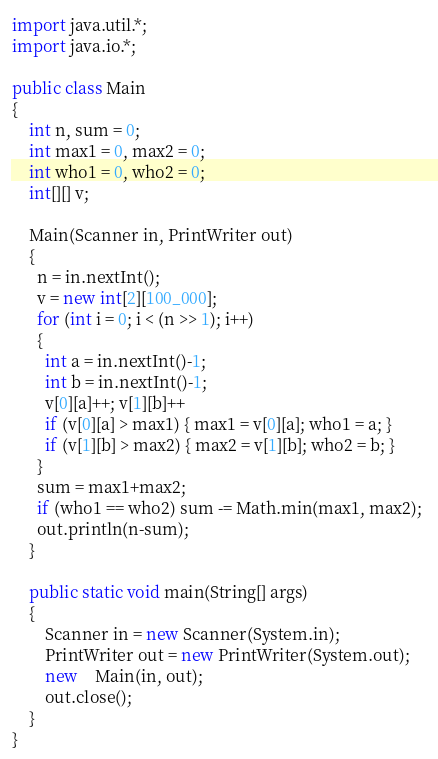<code> <loc_0><loc_0><loc_500><loc_500><_Java_>import java.util.*;
import java.io.*;

public class Main
{
  	int n, sum = 0;
  	int max1 = 0, max2 = 0;
  	int who1 = 0, who2 = 0;
  	int[][] v;
  
    Main(Scanner in, PrintWriter out)
    {
      n = in.nextInt();
      v = new int[2][100_000];
      for (int i = 0; i < (n >> 1); i++)
      {
        int a = in.nextInt()-1;
        int b = in.nextInt()-1;
        v[0][a]++; v[1][b]++
        if (v[0][a] > max1) { max1 = v[0][a]; who1 = a; }
        if (v[1][b] > max2) { max2 = v[1][b]; who2 = b; }
      }
      sum = max1+max2;
      if (who1 == who2) sum -= Math.min(max1, max2); 
      out.println(n-sum);
    }
	
	public static void main(String[] args)
	{
		Scanner in = new Scanner(System.in);
		PrintWriter out = new PrintWriter(System.out);
		new	Main(in, out);
		out.close();
	} 
}</code> 